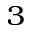<formula> <loc_0><loc_0><loc_500><loc_500>^ { 3 }</formula> 